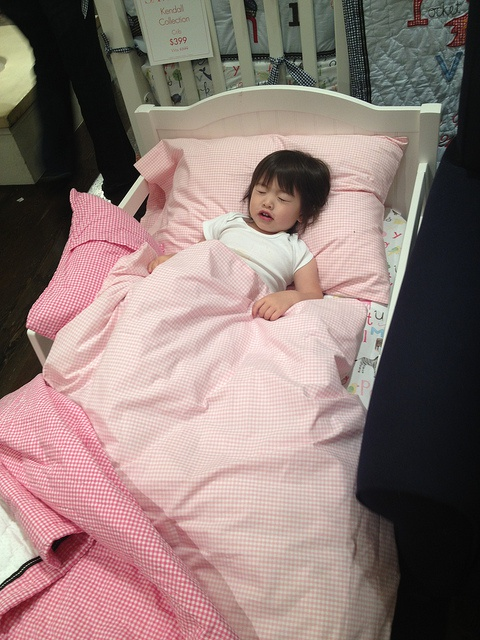Describe the objects in this image and their specific colors. I can see bed in black, lightpink, lightgray, darkgray, and brown tones and people in black, lightgray, tan, and gray tones in this image. 